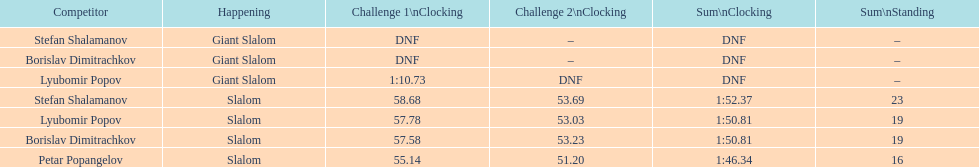Who came after borislav dimitrachkov and it's time for slalom Petar Popangelov. Can you give me this table as a dict? {'header': ['Competitor', 'Happening', 'Challenge 1\\nClocking', 'Challenge 2\\nClocking', 'Sum\\nClocking', 'Sum\\nStanding'], 'rows': [['Stefan Shalamanov', 'Giant Slalom', 'DNF', '–', 'DNF', '–'], ['Borislav Dimitrachkov', 'Giant Slalom', 'DNF', '–', 'DNF', '–'], ['Lyubomir Popov', 'Giant Slalom', '1:10.73', 'DNF', 'DNF', '–'], ['Stefan Shalamanov', 'Slalom', '58.68', '53.69', '1:52.37', '23'], ['Lyubomir Popov', 'Slalom', '57.78', '53.03', '1:50.81', '19'], ['Borislav Dimitrachkov', 'Slalom', '57.58', '53.23', '1:50.81', '19'], ['Petar Popangelov', 'Slalom', '55.14', '51.20', '1:46.34', '16']]} 